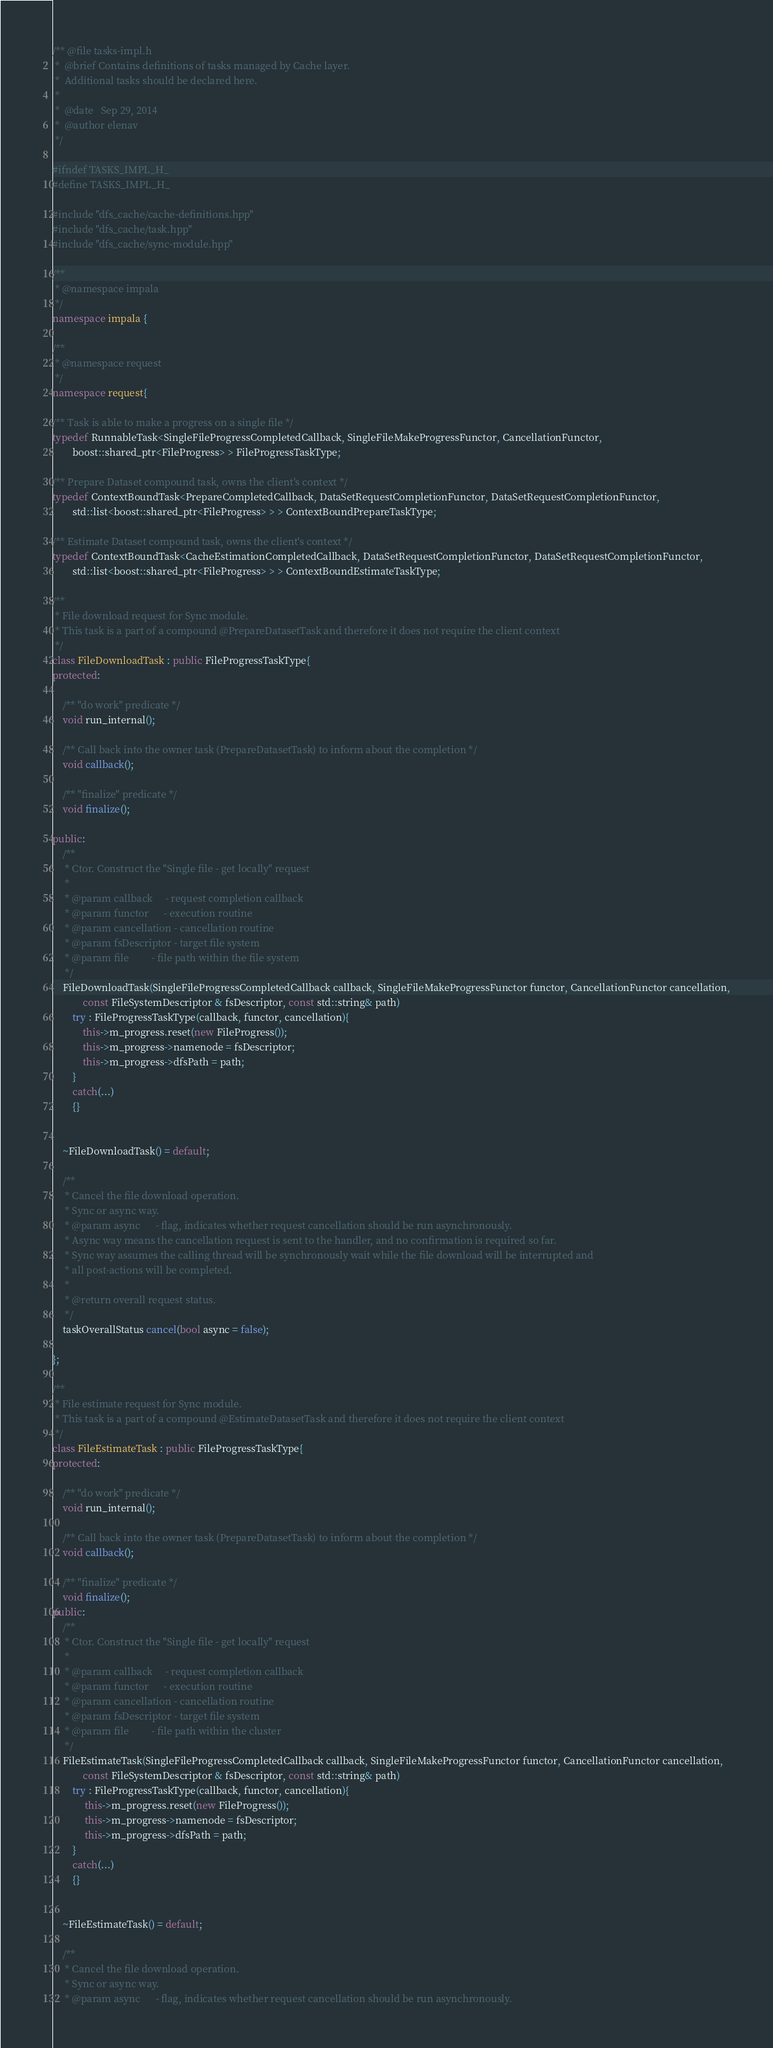<code> <loc_0><loc_0><loc_500><loc_500><_C++_>/** @file tasks-impl.h
 *  @brief Contains definitions of tasks managed by Cache layer.
 *  Additional tasks should be declared here.
 *
 *  @date   Sep 29, 2014
 *  @author elenav
 */

#ifndef TASKS_IMPL_H_
#define TASKS_IMPL_H_

#include "dfs_cache/cache-definitions.hpp"
#include "dfs_cache/task.hpp"
#include "dfs_cache/sync-module.hpp"

/**
 * @namespace impala
 */
namespace impala {

/**
 * @namespace request
 */
namespace request{

/** Task is able to make a progress on a single file */
typedef RunnableTask<SingleFileProgressCompletedCallback, SingleFileMakeProgressFunctor, CancellationFunctor,
		boost::shared_ptr<FileProgress> > FileProgressTaskType;

/** Prepare Dataset compound task, owns the client's context */
typedef ContextBoundTask<PrepareCompletedCallback, DataSetRequestCompletionFunctor, DataSetRequestCompletionFunctor,
		std::list<boost::shared_ptr<FileProgress> > > ContextBoundPrepareTaskType;

/** Estimate Dataset compound task, owns the client's context */
typedef ContextBoundTask<CacheEstimationCompletedCallback, DataSetRequestCompletionFunctor, DataSetRequestCompletionFunctor,
		std::list<boost::shared_ptr<FileProgress> > > ContextBoundEstimateTaskType;

/**
 * File download request for Sync module.
 * This task is a part of a compound @PrepareDatasetTask and therefore it does not require the client context
 */
class FileDownloadTask : public FileProgressTaskType{
protected:

	/** "do work" predicate */
	void run_internal();

	/** Call back into the owner task (PrepareDatasetTask) to inform about the completion */
	void callback();

	/** "finalize" predicate */
	void finalize();

public:
	/**
	 * Ctor. Construct the "Single file - get locally" request
	 *
	 * @param callback     - request completion callback
	 * @param functor      - execution routine
	 * @param cancellation - cancellation routine
	 * @param fsDescriptor - target file system
	 * @param file         - file path within the file system
	 */
	FileDownloadTask(SingleFileProgressCompletedCallback callback, SingleFileMakeProgressFunctor functor, CancellationFunctor cancellation,
			const FileSystemDescriptor & fsDescriptor, const std::string& path)
		try : FileProgressTaskType(callback, functor, cancellation){
			this->m_progress.reset(new FileProgress());
			this->m_progress->namenode = fsDescriptor;
			this->m_progress->dfsPath = path;
		}
		catch(...)
		{}


	~FileDownloadTask() = default;

	/**
	 * Cancel the file download operation.
	 * Sync or async way.
	 * @param async      - flag, indicates whether request cancellation should be run asynchronously.
	 * Async way means the cancellation request is sent to the handler, and no confirmation is required so far.
	 * Sync way assumes the calling thread will be synchronously wait while the file download will be interrupted and
	 * all post-actions will be completed.
	 *
	 * @return overall request status.
	 */
	taskOverallStatus cancel(bool async = false);

};

/**
 * File estimate request for Sync module.
 * This task is a part of a compound @EstimateDatasetTask and therefore it does not require the client context
 */
class FileEstimateTask : public FileProgressTaskType{
protected:

	/** "do work" predicate */
	void run_internal();

	/** Call back into the owner task (PrepareDatasetTask) to inform about the completion */
	void callback();

	/** "finalize" predicate */
	void finalize();
public:
	/**
	 * Ctor. Construct the "Single file - get locally" request
	 *
	 * @param callback     - request completion callback
	 * @param functor      - execution routine
	 * @param cancellation - cancellation routine
	 * @param fsDescriptor - target file system
	 * @param file         - file path within the cluster
	 */
	FileEstimateTask(SingleFileProgressCompletedCallback callback, SingleFileMakeProgressFunctor functor, CancellationFunctor cancellation,
			const FileSystemDescriptor & fsDescriptor, const std::string& path)
		try : FileProgressTaskType(callback, functor, cancellation){
             this->m_progress.reset(new FileProgress());
             this->m_progress->namenode = fsDescriptor;
             this->m_progress->dfsPath = path;
		}
		catch(...)
		{}


	~FileEstimateTask() = default;

	/**
	 * Cancel the file download operation.
	 * Sync or async way.
	 * @param async      - flag, indicates whether request cancellation should be run asynchronously.</code> 